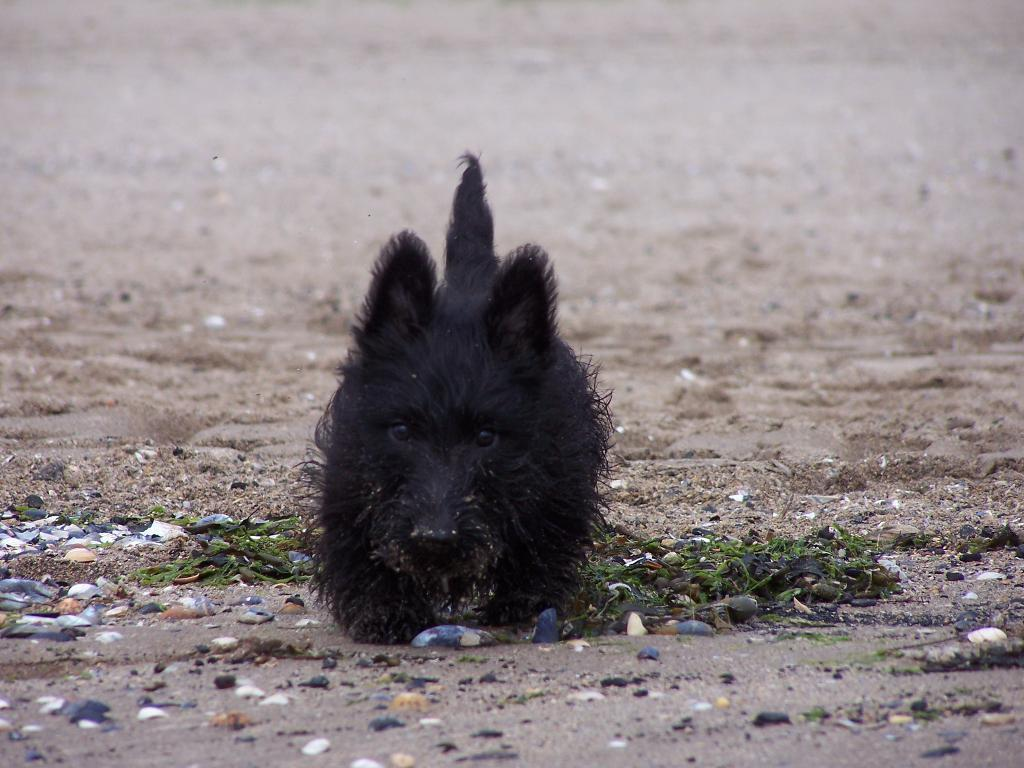What type of animal can be seen in the image? There is a black dog in the image. What is the dog doing in the image? The dog is sitting on the land. What type of terrain is visible in the image? There are stones visible in the image. What can be seen in the background of the image? There is an open land in the background of the image. What is the dog's annual income in the image? The image does not provide information about the dog's income, as it is not relevant to the visual content. 